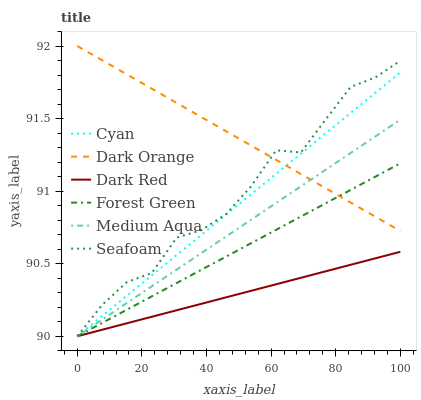Does Dark Red have the minimum area under the curve?
Answer yes or no. Yes. Does Dark Orange have the maximum area under the curve?
Answer yes or no. Yes. Does Seafoam have the minimum area under the curve?
Answer yes or no. No. Does Seafoam have the maximum area under the curve?
Answer yes or no. No. Is Medium Aqua the smoothest?
Answer yes or no. Yes. Is Seafoam the roughest?
Answer yes or no. Yes. Is Dark Red the smoothest?
Answer yes or no. No. Is Dark Red the roughest?
Answer yes or no. No. Does Seafoam have the highest value?
Answer yes or no. No. Is Dark Red less than Dark Orange?
Answer yes or no. Yes. Is Dark Orange greater than Dark Red?
Answer yes or no. Yes. Does Dark Red intersect Dark Orange?
Answer yes or no. No. 